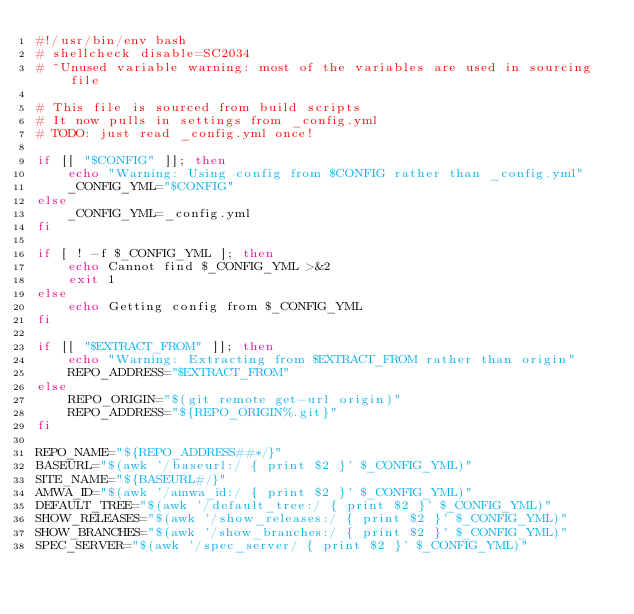Convert code to text. <code><loc_0><loc_0><loc_500><loc_500><_Bash_>#!/usr/bin/env bash
# shellcheck disable=SC2034
# ^Unused variable warning: most of the variables are used in sourcing file

# This file is sourced from build scripts
# It now pulls in settings from _config.yml
# TODO: just read _config.yml once!

if [[ "$CONFIG" ]]; then
    echo "Warning: Using config from $CONFIG rather than _config.yml"
    _CONFIG_YML="$CONFIG"
else
    _CONFIG_YML=_config.yml
fi

if [ ! -f $_CONFIG_YML ]; then
    echo Cannot find $_CONFIG_YML >&2 
    exit 1
else
    echo Getting config from $_CONFIG_YML
fi

if [[ "$EXTRACT_FROM" ]]; then
    echo "Warning: Extracting from $EXTRACT_FROM rather than origin"
    REPO_ADDRESS="$EXTRACT_FROM"
else
    REPO_ORIGIN="$(git remote get-url origin)"
    REPO_ADDRESS="${REPO_ORIGIN%.git}"
fi

REPO_NAME="${REPO_ADDRESS##*/}"
BASEURL="$(awk '/baseurl:/ { print $2 }' $_CONFIG_YML)"
SITE_NAME="${BASEURL#/}"
AMWA_ID="$(awk '/amwa_id:/ { print $2 }' $_CONFIG_YML)"
DEFAULT_TREE="$(awk '/default_tree:/ { print $2 }' $_CONFIG_YML)"
SHOW_RELEASES="$(awk '/show_releases:/ { print $2 }' $_CONFIG_YML)"
SHOW_BRANCHES="$(awk '/show_branches:/ { print $2 }' $_CONFIG_YML)"
SPEC_SERVER="$(awk '/spec_server/ { print $2 }' $_CONFIG_YML)"
</code> 